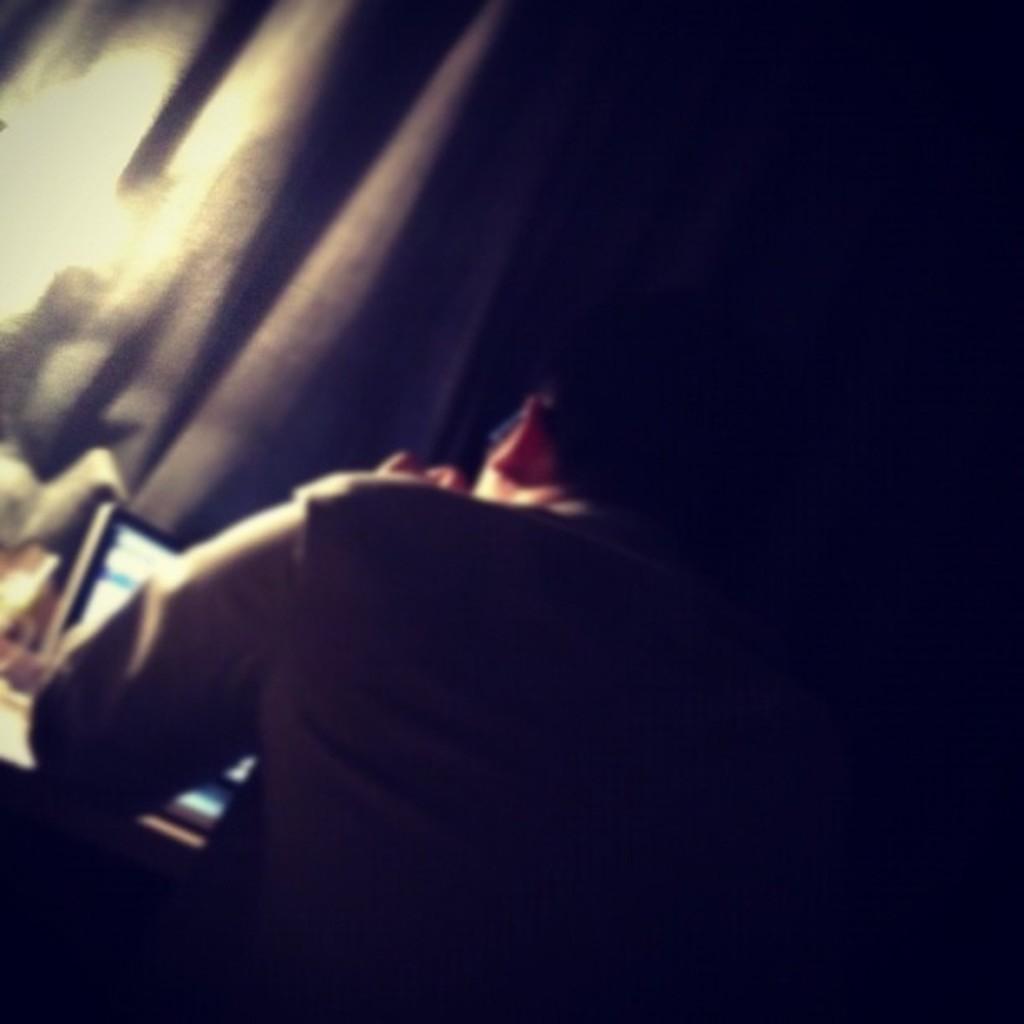Please provide a concise description of this image. Here a man is working in a laptop. 